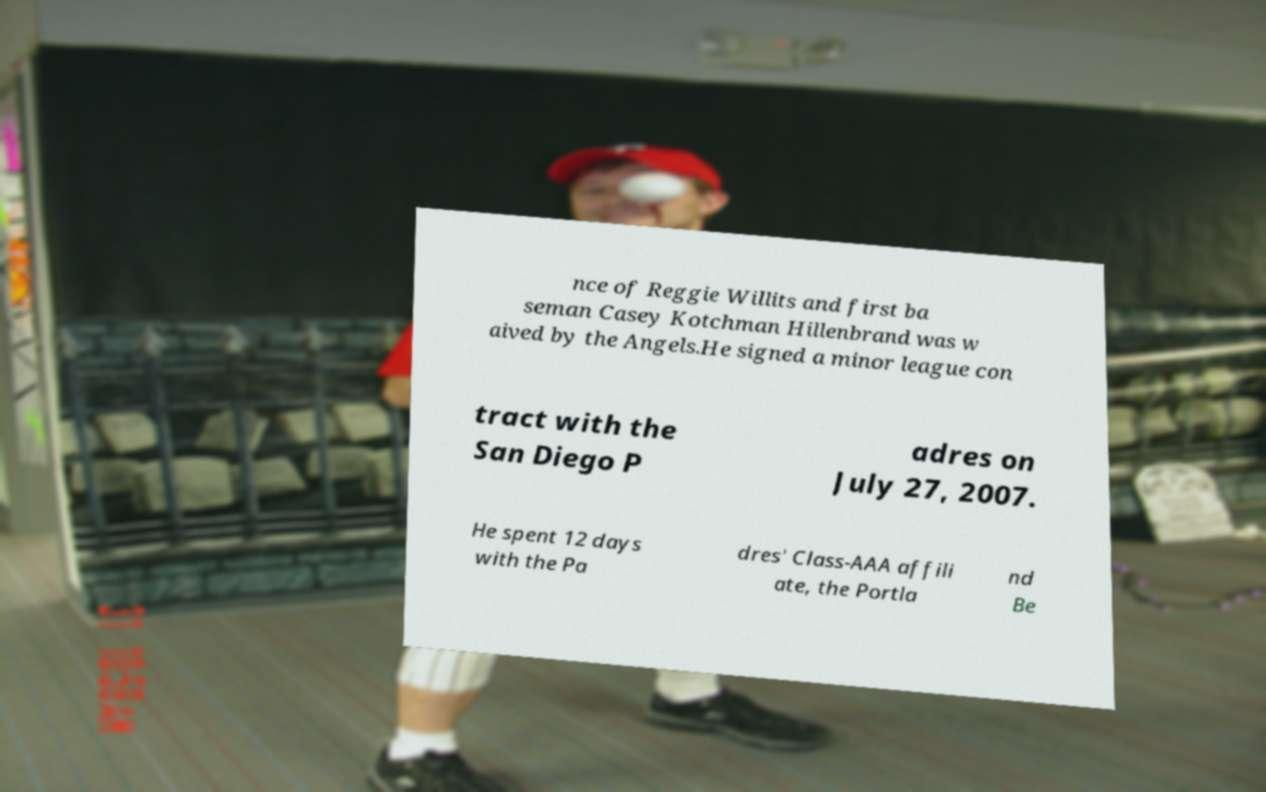Can you read and provide the text displayed in the image?This photo seems to have some interesting text. Can you extract and type it out for me? nce of Reggie Willits and first ba seman Casey Kotchman Hillenbrand was w aived by the Angels.He signed a minor league con tract with the San Diego P adres on July 27, 2007. He spent 12 days with the Pa dres' Class-AAA affili ate, the Portla nd Be 